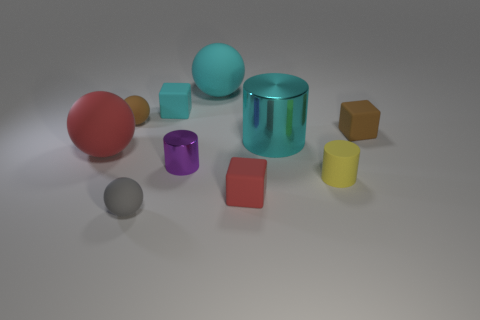Subtract all cylinders. How many objects are left? 7 Add 4 big blue rubber cubes. How many big blue rubber cubes exist? 4 Subtract 0 blue spheres. How many objects are left? 10 Subtract all cyan matte spheres. Subtract all red rubber cylinders. How many objects are left? 9 Add 8 big matte balls. How many big matte balls are left? 10 